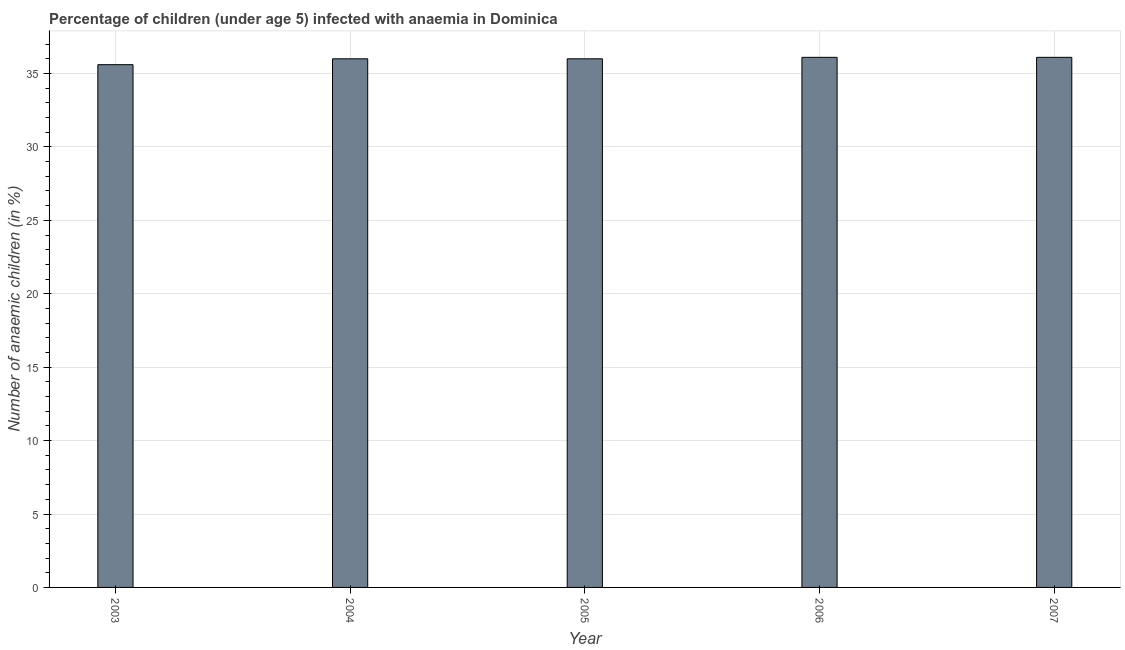Does the graph contain any zero values?
Provide a succinct answer. No. Does the graph contain grids?
Offer a very short reply. Yes. What is the title of the graph?
Keep it short and to the point. Percentage of children (under age 5) infected with anaemia in Dominica. What is the label or title of the X-axis?
Offer a terse response. Year. What is the label or title of the Y-axis?
Provide a succinct answer. Number of anaemic children (in %). What is the number of anaemic children in 2007?
Offer a terse response. 36.1. Across all years, what is the maximum number of anaemic children?
Your answer should be compact. 36.1. Across all years, what is the minimum number of anaemic children?
Make the answer very short. 35.6. In which year was the number of anaemic children minimum?
Ensure brevity in your answer.  2003. What is the sum of the number of anaemic children?
Make the answer very short. 179.8. What is the average number of anaemic children per year?
Give a very brief answer. 35.96. What is the difference between the highest and the second highest number of anaemic children?
Provide a short and direct response. 0. Is the sum of the number of anaemic children in 2003 and 2006 greater than the maximum number of anaemic children across all years?
Your answer should be compact. Yes. In how many years, is the number of anaemic children greater than the average number of anaemic children taken over all years?
Your response must be concise. 4. How many years are there in the graph?
Make the answer very short. 5. Are the values on the major ticks of Y-axis written in scientific E-notation?
Make the answer very short. No. What is the Number of anaemic children (in %) of 2003?
Provide a short and direct response. 35.6. What is the Number of anaemic children (in %) of 2004?
Make the answer very short. 36. What is the Number of anaemic children (in %) in 2005?
Give a very brief answer. 36. What is the Number of anaemic children (in %) of 2006?
Make the answer very short. 36.1. What is the Number of anaemic children (in %) of 2007?
Provide a succinct answer. 36.1. What is the difference between the Number of anaemic children (in %) in 2003 and 2004?
Your answer should be compact. -0.4. What is the difference between the Number of anaemic children (in %) in 2003 and 2005?
Offer a very short reply. -0.4. What is the difference between the Number of anaemic children (in %) in 2003 and 2006?
Provide a short and direct response. -0.5. What is the difference between the Number of anaemic children (in %) in 2003 and 2007?
Ensure brevity in your answer.  -0.5. What is the difference between the Number of anaemic children (in %) in 2004 and 2006?
Offer a very short reply. -0.1. What is the ratio of the Number of anaemic children (in %) in 2003 to that in 2005?
Offer a very short reply. 0.99. What is the ratio of the Number of anaemic children (in %) in 2003 to that in 2007?
Make the answer very short. 0.99. What is the ratio of the Number of anaemic children (in %) in 2004 to that in 2005?
Provide a short and direct response. 1. What is the ratio of the Number of anaemic children (in %) in 2004 to that in 2006?
Give a very brief answer. 1. 